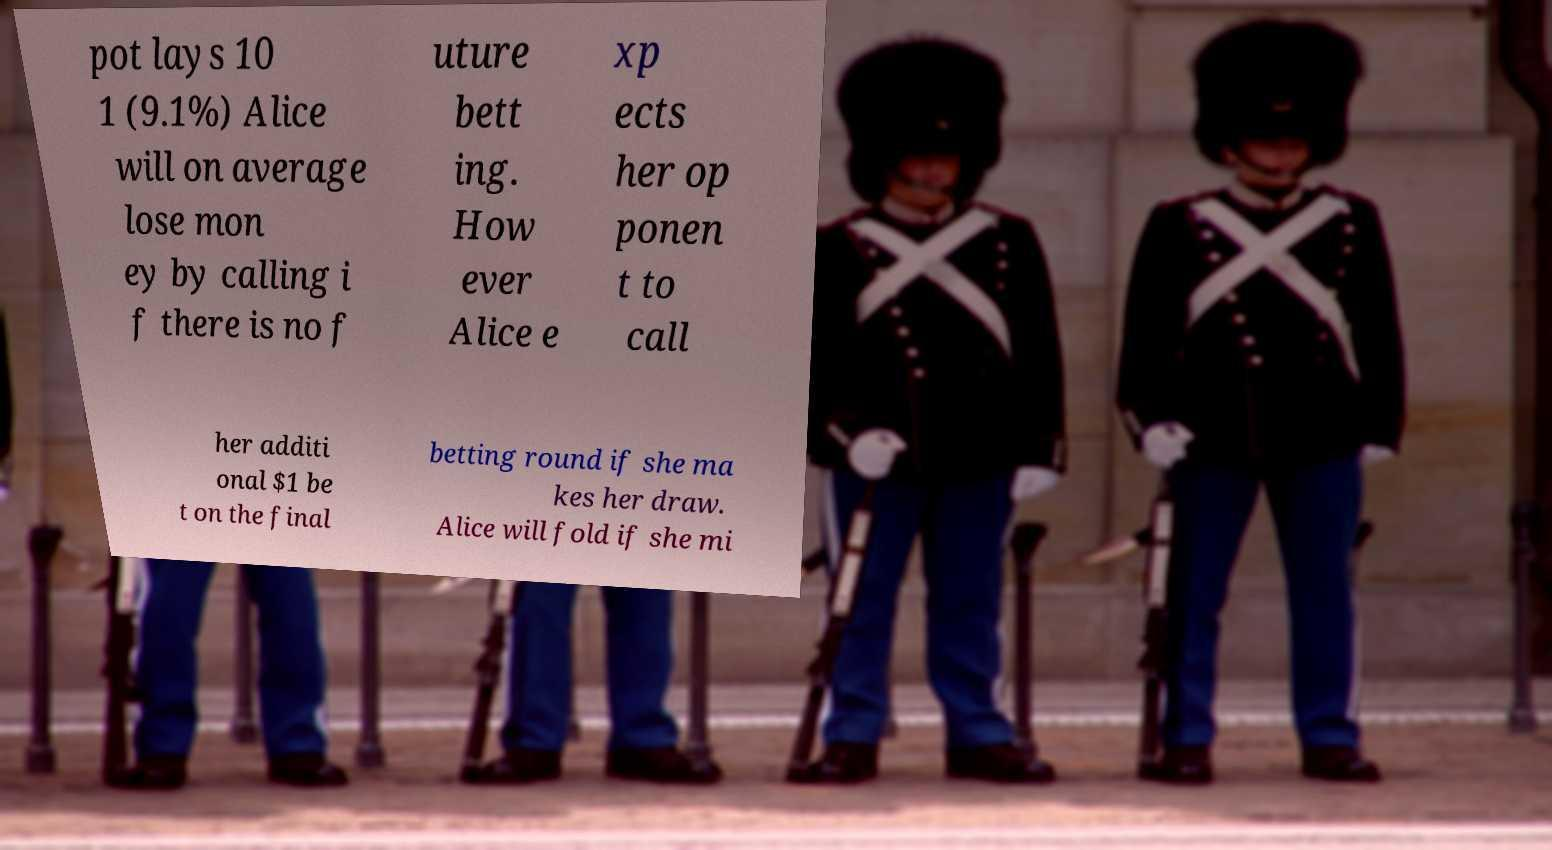Please read and relay the text visible in this image. What does it say? pot lays 10 1 (9.1%) Alice will on average lose mon ey by calling i f there is no f uture bett ing. How ever Alice e xp ects her op ponen t to call her additi onal $1 be t on the final betting round if she ma kes her draw. Alice will fold if she mi 